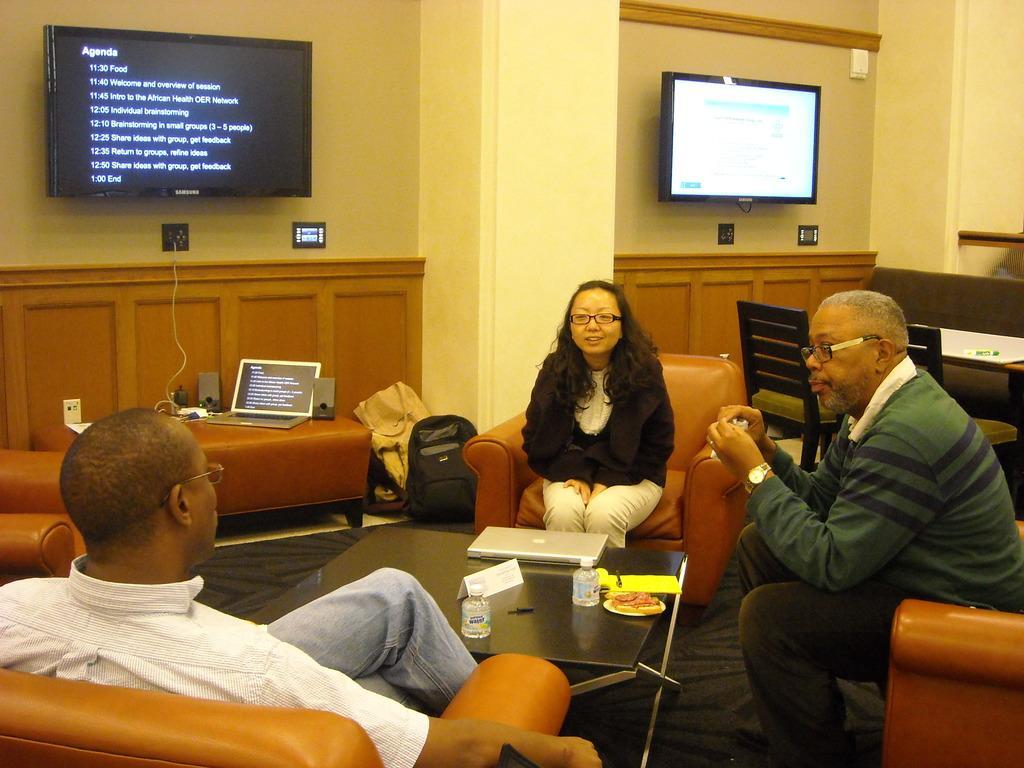Please provide a concise description of this image. In the image we can see there are people sitting on the chairs and there is a laptop, water bottles, name plate card and there is a food item kept on the table. Behind there is a laptop connected to the charger and kept on the table. There are bags kept on the floor and there are two tv screens kept on the wall. There is a paper chart and pen kept on the table and there are chairs kept on the floor. 